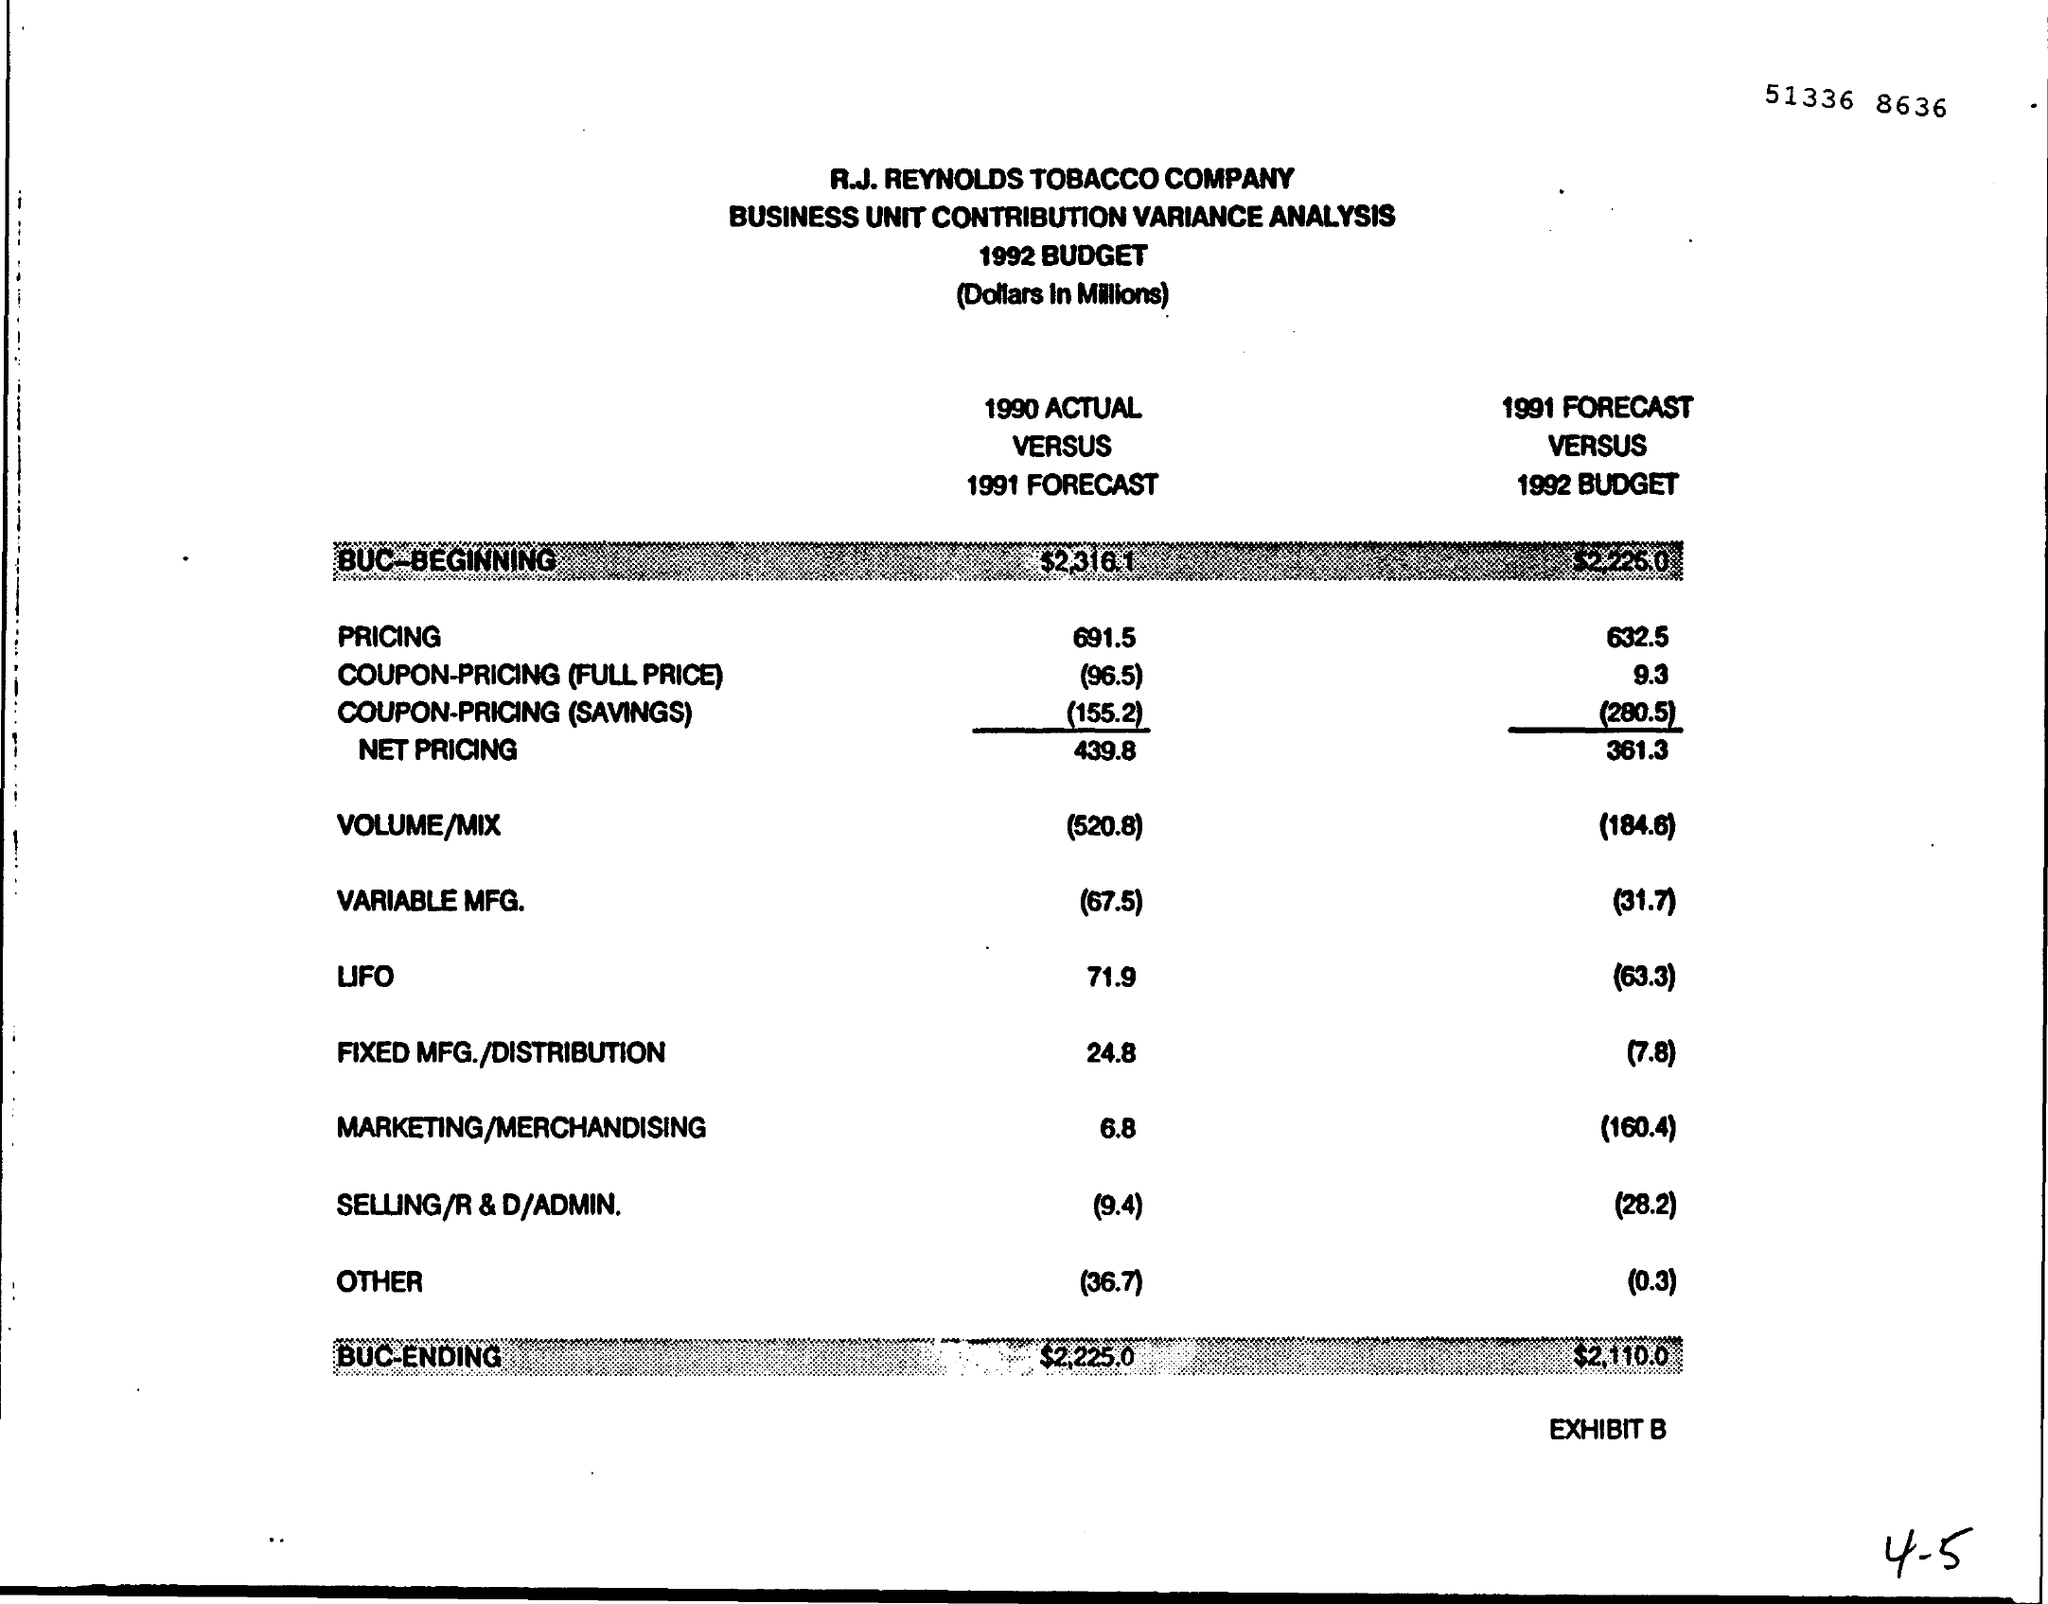What is the pricing of 1990 actual versus 1991 forecast?
Keep it short and to the point. 691.5. 